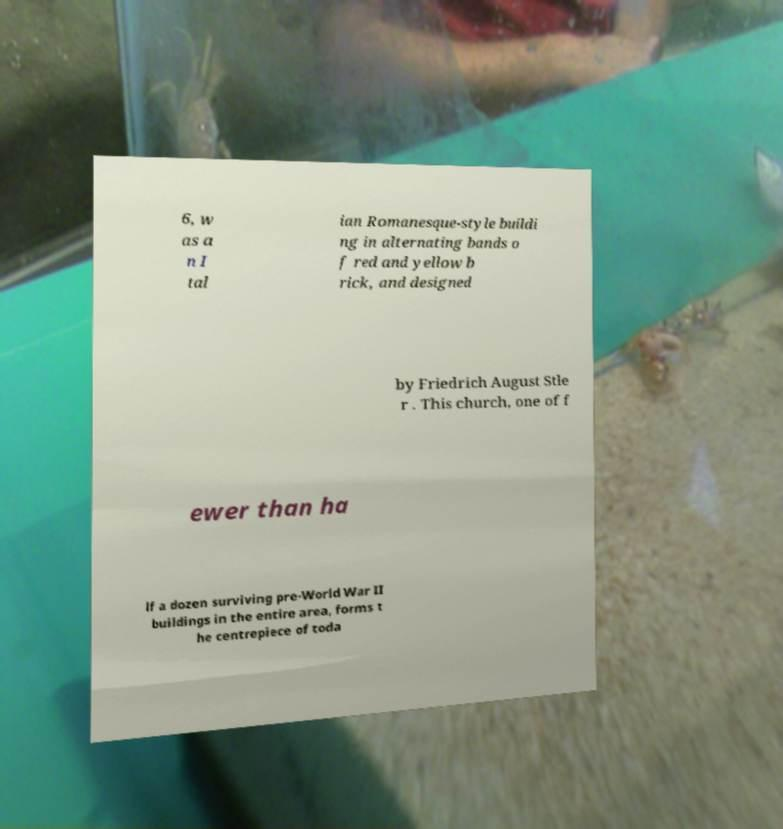Can you accurately transcribe the text from the provided image for me? 6, w as a n I tal ian Romanesque-style buildi ng in alternating bands o f red and yellow b rick, and designed by Friedrich August Stle r . This church, one of f ewer than ha lf a dozen surviving pre-World War II buildings in the entire area, forms t he centrepiece of toda 